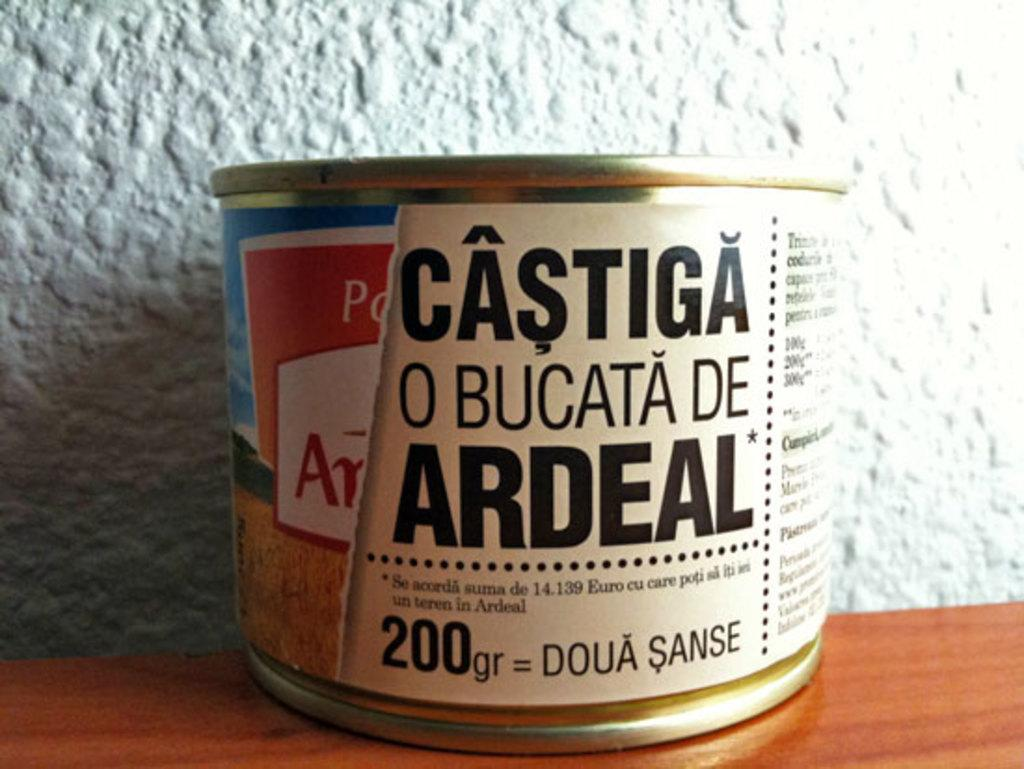What object is visible in the image that has a specific shape? There is a box in the image. What can be found on the surface of the box? The box has text printed on it. Where is the box located in the image? The box is present on a table. What type of tail can be seen on the box in the image? There is no tail present on the box in the image. Is there a cart visible in the image? There is no cart present in the image. 